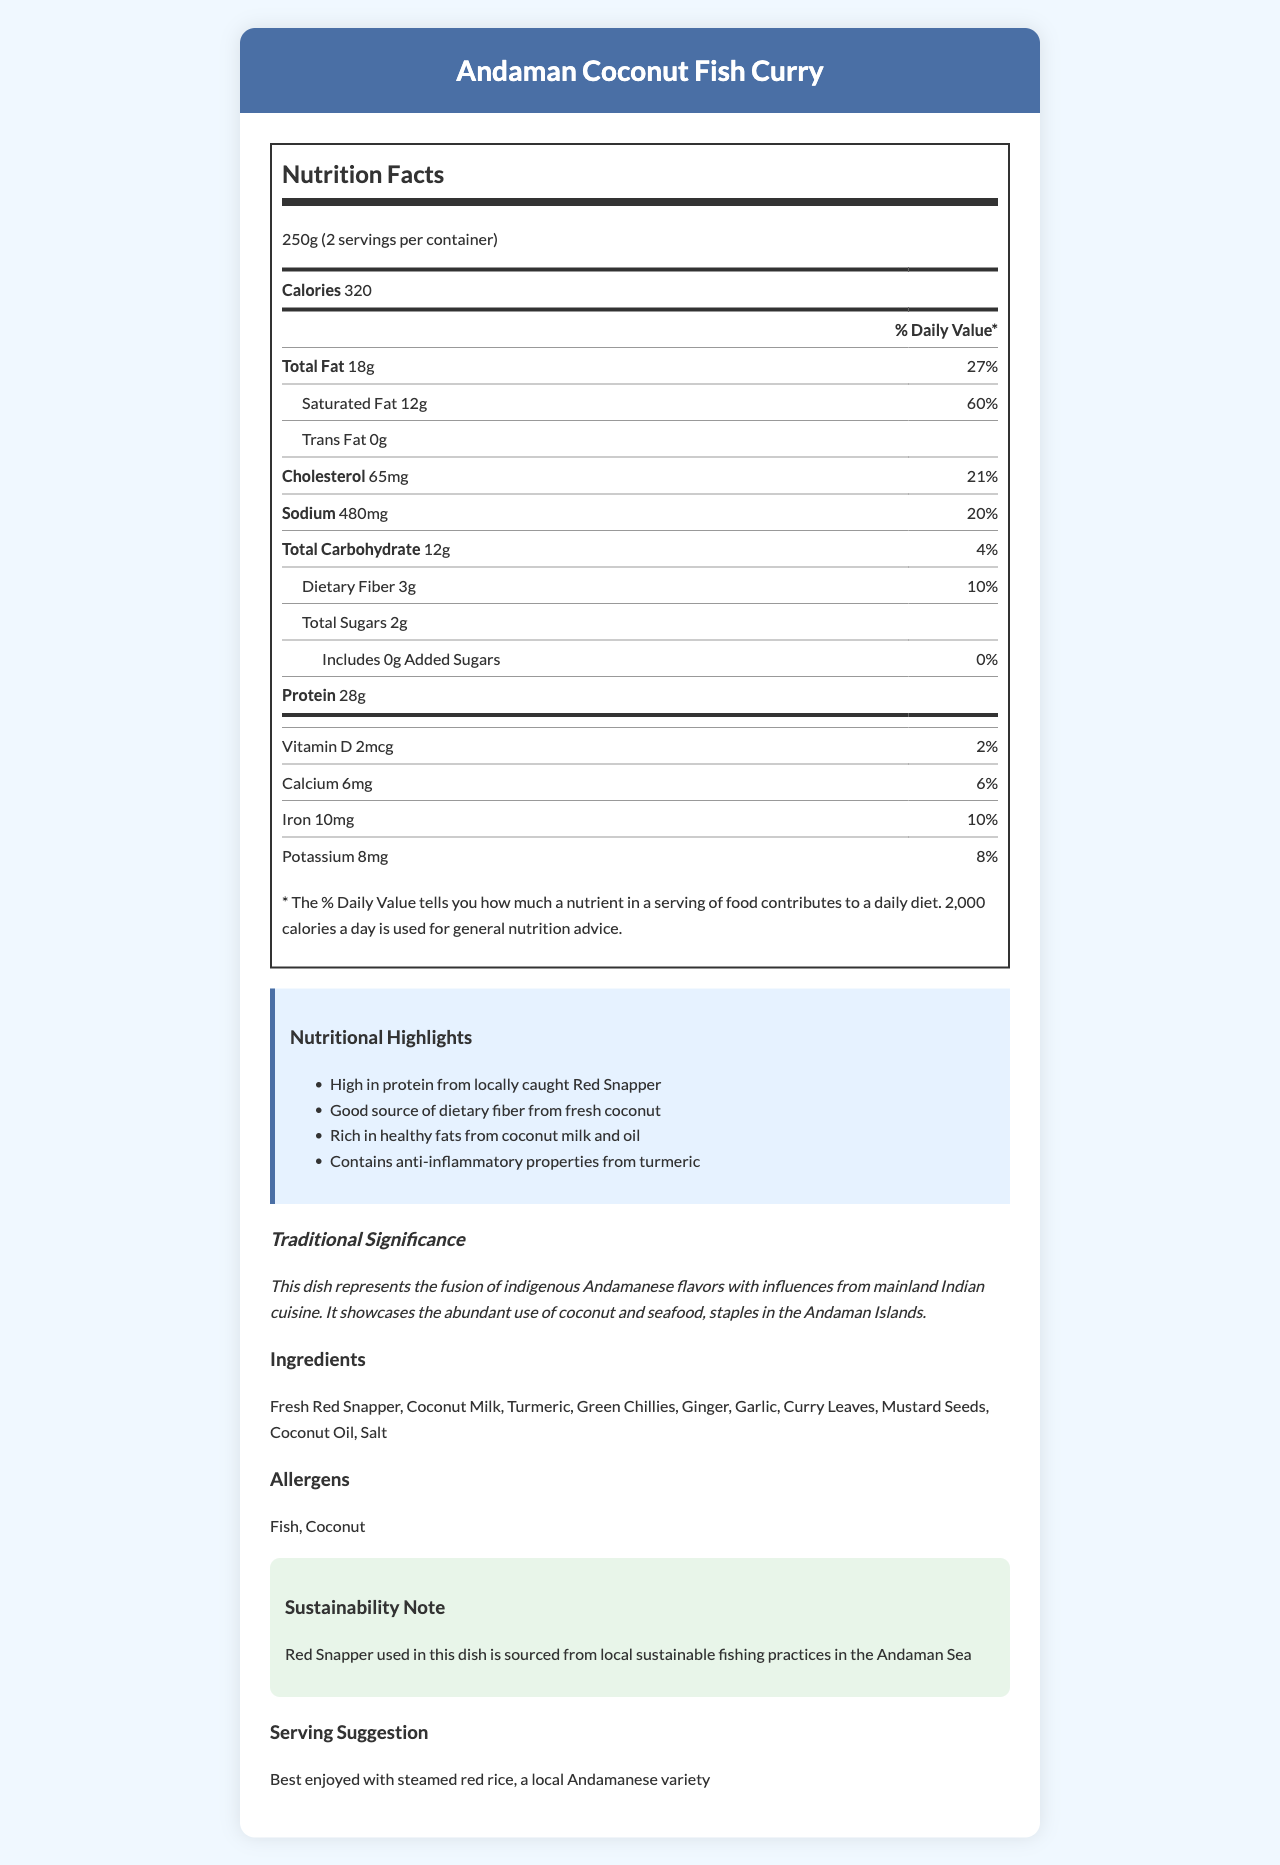What is the serving size? The serving size is clearly indicated in the document as 250g.
Answer: 250g How many servings per container are there? According to the document, there are 2 servings per container.
Answer: 2 How much protein does one serving contain? The nutrition label shows that one serving contains 28g of protein.
Answer: 28g What are the allergens listed for this dish? The document states that the allergens for this dish are Fish and Coconut.
Answer: Fish, Coconut What is the percentage of Daily Value for saturated fat in this dish? The nutrition label shows that the saturated fat content is 12g and represents 60% of the Daily Value.
Answer: 60% Which nutrient has the highest percentage of Daily Value? A. Sodium B. Total Fat C. Cholesterol D. Dietary Fiber The document shows that the total fat has the highest percentage of Daily Value at 27%.
Answer: B How much iron is in one serving? A. 2mg B. 6mg C. 10mg D. 28mg The nutrition facts indicate that one serving contains 10mg of iron.
Answer: C Is the dish high in protein? The nutritional highlights state that the dish is high in protein from locally caught Red Snapper, and the protein content is 28g per serving.
Answer: Yes Summarize the main nutritional highlights of Andaman Coconut Fish Curry. The highlights section of the document mentions these key nutritional features of the dish, emphasizing its protein, fiber, healthy fats, and turmeric's benefits.
Answer: High in protein from locally caught Red Snapper, good source of dietary fiber from fresh coconut, rich in healthy fats from coconut milk and oil, contains anti-inflammatory properties from turmeric. What is the total carbohydrate content per serving and its percentage of the Daily Value? The document shows that the total carbohydrate content is 12g and this equals 4% of the Daily Value.
Answer: 12g, 4% What ingredient in the dish provides most of the healthy fats? According to the nutritional highlights, the dish is rich in healthy fats from coconut milk and oil.
Answer: Coconut Milk and Coconut Oil How does the traditional significance of this dish reflect the cuisine of the Andaman Islands? The document describes the traditional significance, emphasizing the blend of local and mainland flavors, and the use of common local ingredients like coconut and seafood.
Answer: The dish represents the fusion of indigenous Andamanese flavors with influences from mainland Indian cuisine and showcases the abundant use of coconut and seafood, staples in the Andaman Islands. How much sodium is in one serving? The nutrition facts label states that one serving contains 480mg of sodium.
Answer: 480mg Does the dish contain any added sugars? The label specifies that the dish includes 0g of added sugars.
Answer: No How much calcium is in one serving of Andaman Coconut Fish Curry? The nutrition facts label states that one serving contains 6% of the Daily Value for calcium.
Answer: 6% of Daily Value How is the Red Snapper used in this dish sourced? The sustainability note mentions that the Red Snapper is sourced from local sustainable fishing practices.
Answer: From local sustainable fishing practices in the Andaman Sea What is the main source of dietary fiber in Andaman Coconut Fish Curry? The nutritional highlights note that dietary fiber comes from fresh coconut.
Answer: Fresh coconut Based on the document, can we identify the exact amount of vitamin D in grams? The document only provides the percentage of Daily Value (2%) for Vitamin D and not the exact amount in grams.
Answer: Cannot be determined 